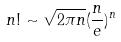Convert formula to latex. <formula><loc_0><loc_0><loc_500><loc_500>n ! \sim \sqrt { 2 \pi n } ( \frac { n } { e } ) ^ { n }</formula> 